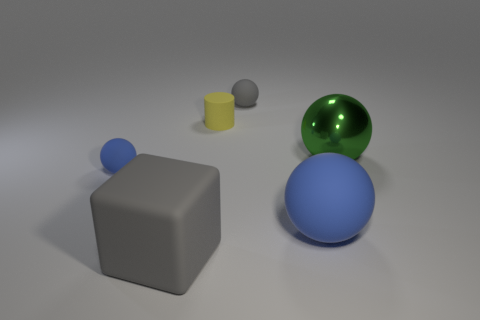Subtract all gray balls. How many balls are left? 3 Subtract all gray cubes. How many blue spheres are left? 2 Subtract all gray spheres. How many spheres are left? 3 Add 3 purple rubber balls. How many objects exist? 9 Subtract all balls. How many objects are left? 2 Subtract 0 cyan balls. How many objects are left? 6 Subtract all brown spheres. Subtract all blue cubes. How many spheres are left? 4 Subtract all green matte things. Subtract all large spheres. How many objects are left? 4 Add 6 large blocks. How many large blocks are left? 7 Add 5 large blue matte balls. How many large blue matte balls exist? 6 